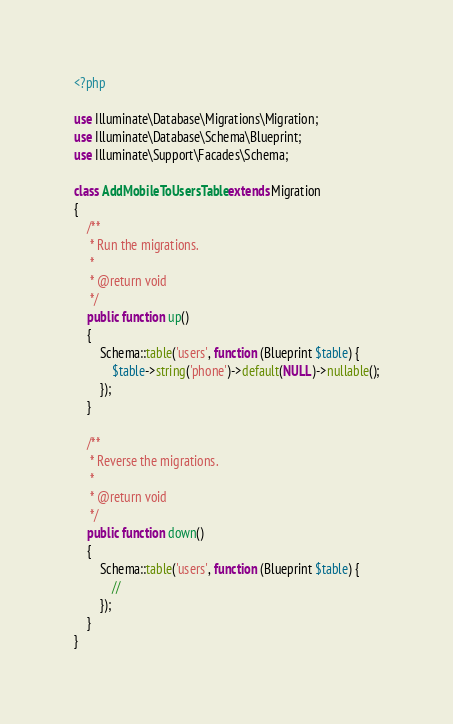<code> <loc_0><loc_0><loc_500><loc_500><_PHP_><?php

use Illuminate\Database\Migrations\Migration;
use Illuminate\Database\Schema\Blueprint;
use Illuminate\Support\Facades\Schema;

class AddMobileToUsersTable extends Migration
{
    /**
     * Run the migrations.
     *
     * @return void
     */
    public function up()
    {
        Schema::table('users', function (Blueprint $table) {
            $table->string('phone')->default(NULL)->nullable();
        });
    }

    /**
     * Reverse the migrations.
     *
     * @return void
     */
    public function down()
    {
        Schema::table('users', function (Blueprint $table) {
            //
        });
    }
}
</code> 